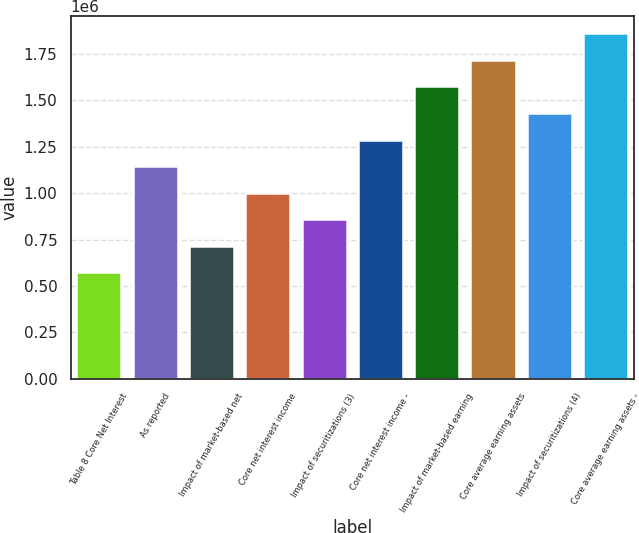Convert chart. <chart><loc_0><loc_0><loc_500><loc_500><bar_chart><fcel>Table 8 Core Net Interest<fcel>As reported<fcel>Impact of market-based net<fcel>Core net interest income<fcel>Impact of securitizations (3)<fcel>Core net interest income -<fcel>Impact of market-based earning<fcel>Core average earning assets<fcel>Impact of securitizations (4)<fcel>Core average earning assets -<nl><fcel>572917<fcel>1.14583e+06<fcel>716146<fcel>1.0026e+06<fcel>859375<fcel>1.28906e+06<fcel>1.57552e+06<fcel>1.71875e+06<fcel>1.43229e+06<fcel>1.86198e+06<nl></chart> 